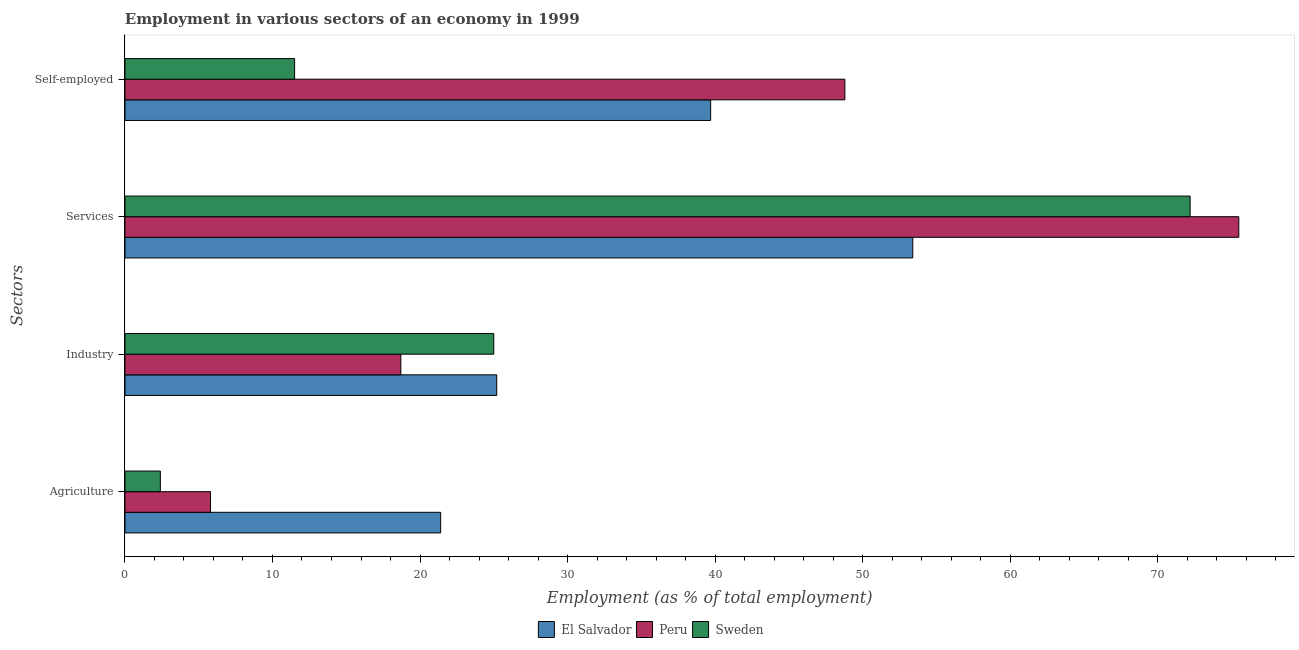How many groups of bars are there?
Offer a terse response. 4. Are the number of bars on each tick of the Y-axis equal?
Keep it short and to the point. Yes. How many bars are there on the 2nd tick from the bottom?
Offer a very short reply. 3. What is the label of the 1st group of bars from the top?
Offer a terse response. Self-employed. What is the percentage of workers in services in Peru?
Make the answer very short. 75.5. Across all countries, what is the maximum percentage of workers in services?
Keep it short and to the point. 75.5. Across all countries, what is the minimum percentage of self employed workers?
Ensure brevity in your answer.  11.5. In which country was the percentage of self employed workers maximum?
Provide a short and direct response. Peru. In which country was the percentage of workers in services minimum?
Keep it short and to the point. El Salvador. What is the total percentage of workers in agriculture in the graph?
Give a very brief answer. 29.6. What is the difference between the percentage of workers in services in Peru and that in Sweden?
Give a very brief answer. 3.3. What is the difference between the percentage of workers in agriculture in El Salvador and the percentage of self employed workers in Peru?
Provide a succinct answer. -27.4. What is the average percentage of self employed workers per country?
Ensure brevity in your answer.  33.33. What is the difference between the percentage of workers in agriculture and percentage of self employed workers in El Salvador?
Your answer should be very brief. -18.3. In how many countries, is the percentage of workers in services greater than 6 %?
Ensure brevity in your answer.  3. What is the ratio of the percentage of workers in agriculture in Sweden to that in El Salvador?
Keep it short and to the point. 0.11. Is the percentage of workers in agriculture in Peru less than that in El Salvador?
Provide a short and direct response. Yes. Is the difference between the percentage of workers in services in Peru and Sweden greater than the difference between the percentage of workers in industry in Peru and Sweden?
Offer a very short reply. Yes. What is the difference between the highest and the second highest percentage of workers in services?
Keep it short and to the point. 3.3. What is the difference between the highest and the lowest percentage of workers in services?
Your answer should be compact. 22.1. Is the sum of the percentage of workers in services in Peru and Sweden greater than the maximum percentage of workers in agriculture across all countries?
Your answer should be compact. Yes. Is it the case that in every country, the sum of the percentage of workers in agriculture and percentage of workers in services is greater than the sum of percentage of workers in industry and percentage of self employed workers?
Provide a succinct answer. Yes. What does the 3rd bar from the top in Industry represents?
Your response must be concise. El Salvador. How many bars are there?
Give a very brief answer. 12. Are all the bars in the graph horizontal?
Provide a succinct answer. Yes. Where does the legend appear in the graph?
Provide a succinct answer. Bottom center. How many legend labels are there?
Give a very brief answer. 3. How are the legend labels stacked?
Your response must be concise. Horizontal. What is the title of the graph?
Your answer should be compact. Employment in various sectors of an economy in 1999. What is the label or title of the X-axis?
Ensure brevity in your answer.  Employment (as % of total employment). What is the label or title of the Y-axis?
Give a very brief answer. Sectors. What is the Employment (as % of total employment) of El Salvador in Agriculture?
Make the answer very short. 21.4. What is the Employment (as % of total employment) in Peru in Agriculture?
Keep it short and to the point. 5.8. What is the Employment (as % of total employment) of Sweden in Agriculture?
Ensure brevity in your answer.  2.4. What is the Employment (as % of total employment) of El Salvador in Industry?
Your answer should be very brief. 25.2. What is the Employment (as % of total employment) of Peru in Industry?
Make the answer very short. 18.7. What is the Employment (as % of total employment) in Sweden in Industry?
Give a very brief answer. 25. What is the Employment (as % of total employment) in El Salvador in Services?
Offer a very short reply. 53.4. What is the Employment (as % of total employment) of Peru in Services?
Give a very brief answer. 75.5. What is the Employment (as % of total employment) of Sweden in Services?
Offer a very short reply. 72.2. What is the Employment (as % of total employment) of El Salvador in Self-employed?
Offer a very short reply. 39.7. What is the Employment (as % of total employment) of Peru in Self-employed?
Provide a short and direct response. 48.8. Across all Sectors, what is the maximum Employment (as % of total employment) of El Salvador?
Your response must be concise. 53.4. Across all Sectors, what is the maximum Employment (as % of total employment) of Peru?
Provide a succinct answer. 75.5. Across all Sectors, what is the maximum Employment (as % of total employment) of Sweden?
Your answer should be very brief. 72.2. Across all Sectors, what is the minimum Employment (as % of total employment) in El Salvador?
Your answer should be very brief. 21.4. Across all Sectors, what is the minimum Employment (as % of total employment) of Peru?
Ensure brevity in your answer.  5.8. Across all Sectors, what is the minimum Employment (as % of total employment) of Sweden?
Make the answer very short. 2.4. What is the total Employment (as % of total employment) of El Salvador in the graph?
Offer a terse response. 139.7. What is the total Employment (as % of total employment) in Peru in the graph?
Give a very brief answer. 148.8. What is the total Employment (as % of total employment) of Sweden in the graph?
Your answer should be compact. 111.1. What is the difference between the Employment (as % of total employment) in El Salvador in Agriculture and that in Industry?
Provide a short and direct response. -3.8. What is the difference between the Employment (as % of total employment) in Sweden in Agriculture and that in Industry?
Ensure brevity in your answer.  -22.6. What is the difference between the Employment (as % of total employment) in El Salvador in Agriculture and that in Services?
Keep it short and to the point. -32. What is the difference between the Employment (as % of total employment) of Peru in Agriculture and that in Services?
Ensure brevity in your answer.  -69.7. What is the difference between the Employment (as % of total employment) in Sweden in Agriculture and that in Services?
Make the answer very short. -69.8. What is the difference between the Employment (as % of total employment) of El Salvador in Agriculture and that in Self-employed?
Provide a succinct answer. -18.3. What is the difference between the Employment (as % of total employment) in Peru in Agriculture and that in Self-employed?
Ensure brevity in your answer.  -43. What is the difference between the Employment (as % of total employment) of El Salvador in Industry and that in Services?
Keep it short and to the point. -28.2. What is the difference between the Employment (as % of total employment) of Peru in Industry and that in Services?
Provide a succinct answer. -56.8. What is the difference between the Employment (as % of total employment) of Sweden in Industry and that in Services?
Make the answer very short. -47.2. What is the difference between the Employment (as % of total employment) in Peru in Industry and that in Self-employed?
Your answer should be compact. -30.1. What is the difference between the Employment (as % of total employment) of Peru in Services and that in Self-employed?
Provide a succinct answer. 26.7. What is the difference between the Employment (as % of total employment) of Sweden in Services and that in Self-employed?
Your answer should be very brief. 60.7. What is the difference between the Employment (as % of total employment) in Peru in Agriculture and the Employment (as % of total employment) in Sweden in Industry?
Keep it short and to the point. -19.2. What is the difference between the Employment (as % of total employment) of El Salvador in Agriculture and the Employment (as % of total employment) of Peru in Services?
Make the answer very short. -54.1. What is the difference between the Employment (as % of total employment) in El Salvador in Agriculture and the Employment (as % of total employment) in Sweden in Services?
Provide a succinct answer. -50.8. What is the difference between the Employment (as % of total employment) of Peru in Agriculture and the Employment (as % of total employment) of Sweden in Services?
Your answer should be compact. -66.4. What is the difference between the Employment (as % of total employment) of El Salvador in Agriculture and the Employment (as % of total employment) of Peru in Self-employed?
Give a very brief answer. -27.4. What is the difference between the Employment (as % of total employment) of Peru in Agriculture and the Employment (as % of total employment) of Sweden in Self-employed?
Your response must be concise. -5.7. What is the difference between the Employment (as % of total employment) in El Salvador in Industry and the Employment (as % of total employment) in Peru in Services?
Your answer should be very brief. -50.3. What is the difference between the Employment (as % of total employment) in El Salvador in Industry and the Employment (as % of total employment) in Sweden in Services?
Offer a terse response. -47. What is the difference between the Employment (as % of total employment) in Peru in Industry and the Employment (as % of total employment) in Sweden in Services?
Your answer should be compact. -53.5. What is the difference between the Employment (as % of total employment) of El Salvador in Industry and the Employment (as % of total employment) of Peru in Self-employed?
Provide a succinct answer. -23.6. What is the difference between the Employment (as % of total employment) in El Salvador in Services and the Employment (as % of total employment) in Peru in Self-employed?
Keep it short and to the point. 4.6. What is the difference between the Employment (as % of total employment) in El Salvador in Services and the Employment (as % of total employment) in Sweden in Self-employed?
Provide a short and direct response. 41.9. What is the difference between the Employment (as % of total employment) in Peru in Services and the Employment (as % of total employment) in Sweden in Self-employed?
Your answer should be compact. 64. What is the average Employment (as % of total employment) in El Salvador per Sectors?
Your answer should be compact. 34.92. What is the average Employment (as % of total employment) of Peru per Sectors?
Make the answer very short. 37.2. What is the average Employment (as % of total employment) of Sweden per Sectors?
Your answer should be very brief. 27.77. What is the difference between the Employment (as % of total employment) in El Salvador and Employment (as % of total employment) in Sweden in Agriculture?
Provide a succinct answer. 19. What is the difference between the Employment (as % of total employment) of Peru and Employment (as % of total employment) of Sweden in Agriculture?
Make the answer very short. 3.4. What is the difference between the Employment (as % of total employment) in El Salvador and Employment (as % of total employment) in Peru in Industry?
Offer a terse response. 6.5. What is the difference between the Employment (as % of total employment) of El Salvador and Employment (as % of total employment) of Sweden in Industry?
Offer a very short reply. 0.2. What is the difference between the Employment (as % of total employment) in Peru and Employment (as % of total employment) in Sweden in Industry?
Provide a short and direct response. -6.3. What is the difference between the Employment (as % of total employment) of El Salvador and Employment (as % of total employment) of Peru in Services?
Offer a terse response. -22.1. What is the difference between the Employment (as % of total employment) in El Salvador and Employment (as % of total employment) in Sweden in Services?
Your answer should be compact. -18.8. What is the difference between the Employment (as % of total employment) in El Salvador and Employment (as % of total employment) in Peru in Self-employed?
Your answer should be compact. -9.1. What is the difference between the Employment (as % of total employment) in El Salvador and Employment (as % of total employment) in Sweden in Self-employed?
Provide a short and direct response. 28.2. What is the difference between the Employment (as % of total employment) in Peru and Employment (as % of total employment) in Sweden in Self-employed?
Offer a terse response. 37.3. What is the ratio of the Employment (as % of total employment) in El Salvador in Agriculture to that in Industry?
Your answer should be compact. 0.85. What is the ratio of the Employment (as % of total employment) of Peru in Agriculture to that in Industry?
Provide a short and direct response. 0.31. What is the ratio of the Employment (as % of total employment) of Sweden in Agriculture to that in Industry?
Your answer should be very brief. 0.1. What is the ratio of the Employment (as % of total employment) of El Salvador in Agriculture to that in Services?
Make the answer very short. 0.4. What is the ratio of the Employment (as % of total employment) in Peru in Agriculture to that in Services?
Your response must be concise. 0.08. What is the ratio of the Employment (as % of total employment) in Sweden in Agriculture to that in Services?
Your answer should be very brief. 0.03. What is the ratio of the Employment (as % of total employment) in El Salvador in Agriculture to that in Self-employed?
Provide a succinct answer. 0.54. What is the ratio of the Employment (as % of total employment) in Peru in Agriculture to that in Self-employed?
Keep it short and to the point. 0.12. What is the ratio of the Employment (as % of total employment) in Sweden in Agriculture to that in Self-employed?
Your answer should be compact. 0.21. What is the ratio of the Employment (as % of total employment) in El Salvador in Industry to that in Services?
Offer a terse response. 0.47. What is the ratio of the Employment (as % of total employment) in Peru in Industry to that in Services?
Offer a terse response. 0.25. What is the ratio of the Employment (as % of total employment) in Sweden in Industry to that in Services?
Provide a short and direct response. 0.35. What is the ratio of the Employment (as % of total employment) in El Salvador in Industry to that in Self-employed?
Your response must be concise. 0.63. What is the ratio of the Employment (as % of total employment) of Peru in Industry to that in Self-employed?
Your answer should be very brief. 0.38. What is the ratio of the Employment (as % of total employment) of Sweden in Industry to that in Self-employed?
Ensure brevity in your answer.  2.17. What is the ratio of the Employment (as % of total employment) in El Salvador in Services to that in Self-employed?
Your answer should be compact. 1.35. What is the ratio of the Employment (as % of total employment) of Peru in Services to that in Self-employed?
Your response must be concise. 1.55. What is the ratio of the Employment (as % of total employment) in Sweden in Services to that in Self-employed?
Ensure brevity in your answer.  6.28. What is the difference between the highest and the second highest Employment (as % of total employment) in Peru?
Provide a succinct answer. 26.7. What is the difference between the highest and the second highest Employment (as % of total employment) of Sweden?
Offer a very short reply. 47.2. What is the difference between the highest and the lowest Employment (as % of total employment) in El Salvador?
Give a very brief answer. 32. What is the difference between the highest and the lowest Employment (as % of total employment) of Peru?
Ensure brevity in your answer.  69.7. What is the difference between the highest and the lowest Employment (as % of total employment) of Sweden?
Ensure brevity in your answer.  69.8. 